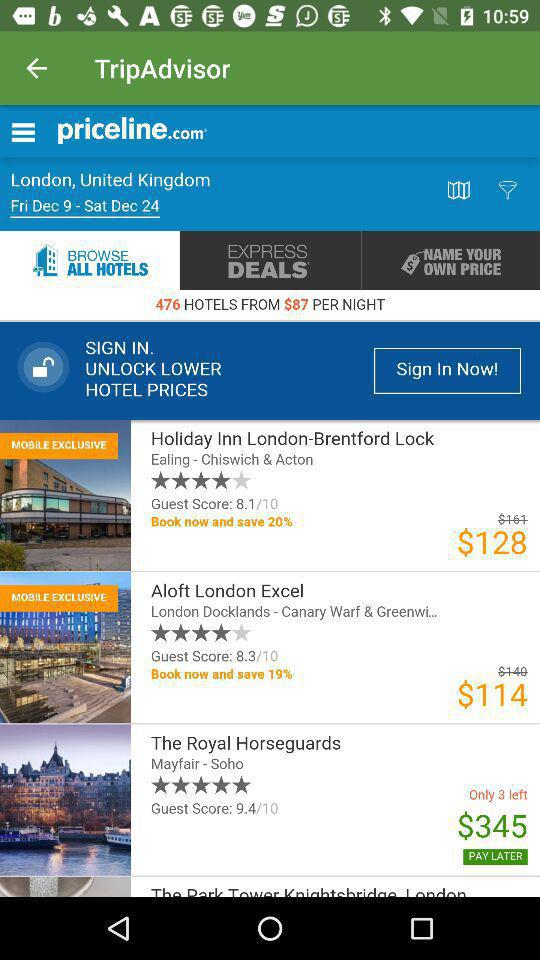What is the rating of the hotel "Holiday Inn London-Brentford Lock"? The rating of the hotel "Holiday Inn London-Brentford Lock" is 4 stars. 